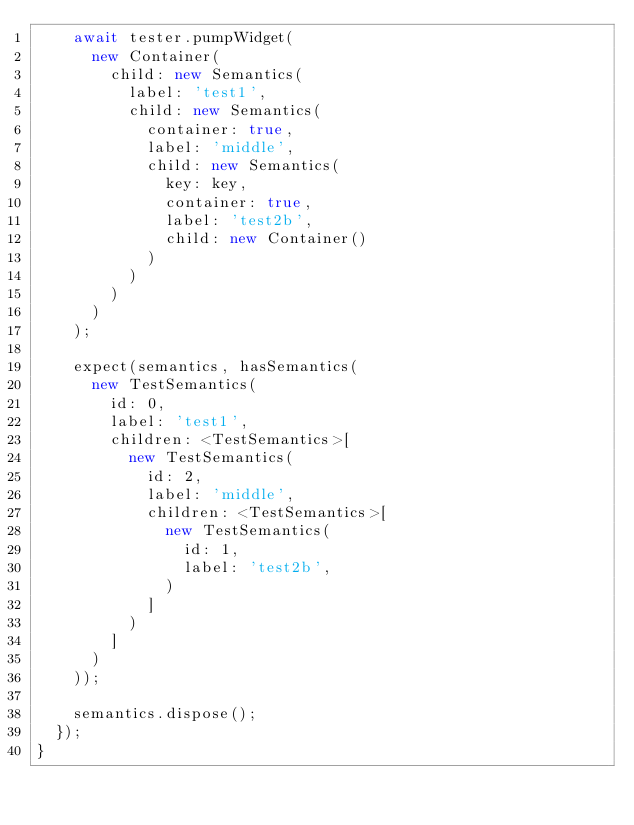Convert code to text. <code><loc_0><loc_0><loc_500><loc_500><_Dart_>    await tester.pumpWidget(
      new Container(
        child: new Semantics(
          label: 'test1',
          child: new Semantics(
            container: true,
            label: 'middle',
            child: new Semantics(
              key: key,
              container: true,
              label: 'test2b',
              child: new Container()
            )
          )
        )
      )
    );

    expect(semantics, hasSemantics(
      new TestSemantics(
        id: 0,
        label: 'test1',
        children: <TestSemantics>[
          new TestSemantics(
            id: 2,
            label: 'middle',
            children: <TestSemantics>[
              new TestSemantics(
                id: 1,
                label: 'test2b',
              )
            ]
          )
        ]
      )
    ));

    semantics.dispose();
  });
}
</code> 